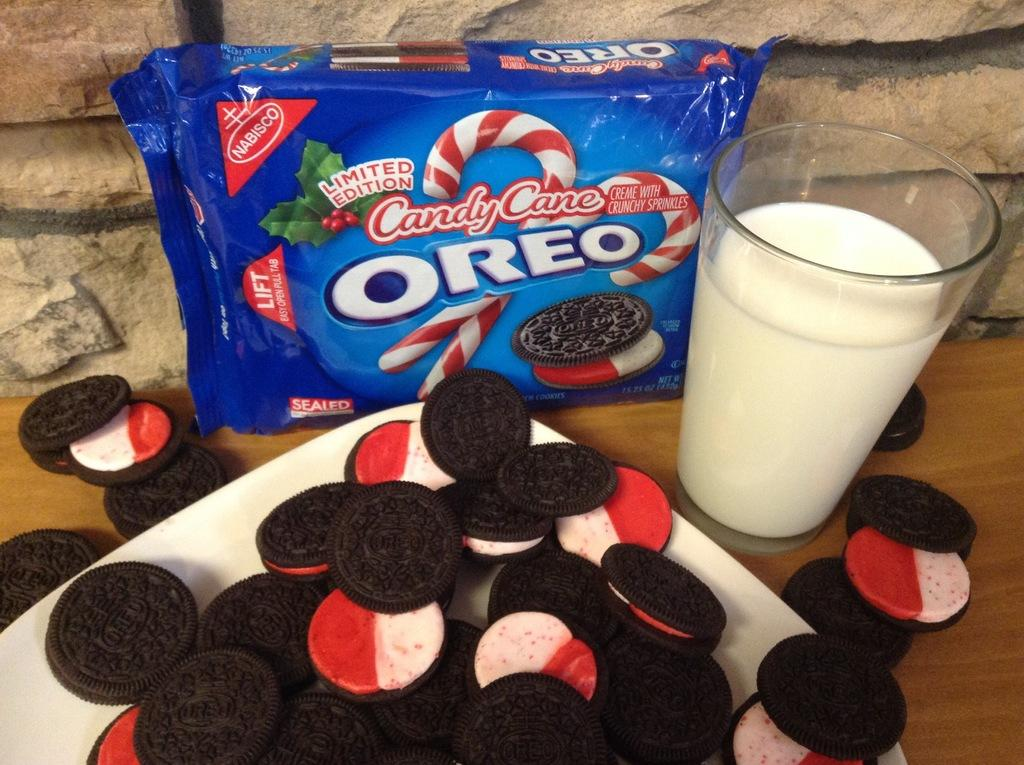What type of food is on the plate in the image? There are cream biscuits on a plate in the image. What material is the surface that the plate is on? There is a wooden surface in the image. What is inside the packet in the image? The contents of the packet are not visible in the image. What is in the glass in the image? There is milk in the glass in the image. What can be seen in the background of the image? There is a stone wall in the background of the image. What type of shoes are being organized for the business meeting in the image? There are no shoes, organization, or business meeting present in the image. 